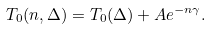<formula> <loc_0><loc_0><loc_500><loc_500>T _ { 0 } ( n , \Delta ) = T _ { 0 } ( \Delta ) + A e ^ { - n \gamma } .</formula> 